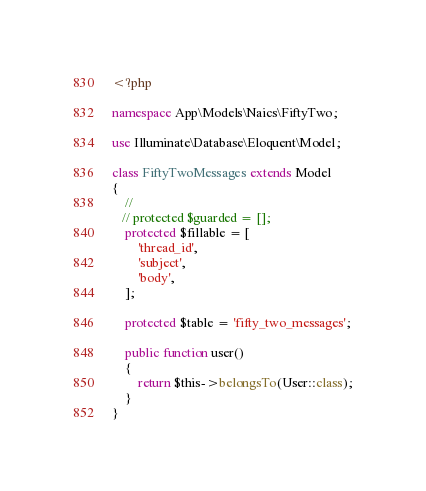Convert code to text. <code><loc_0><loc_0><loc_500><loc_500><_PHP_><?php

namespace App\Models\Naics\FiftyTwo;

use Illuminate\Database\Eloquent\Model;

class FiftyTwoMessages extends Model
{
    //
   // protected $guarded = [];
    protected $fillable = [
        'thread_id',
        'subject',
        'body',
    ];

    protected $table = 'fifty_two_messages';

    public function user()
    {
        return $this->belongsTo(User::class);
    }
}
</code> 